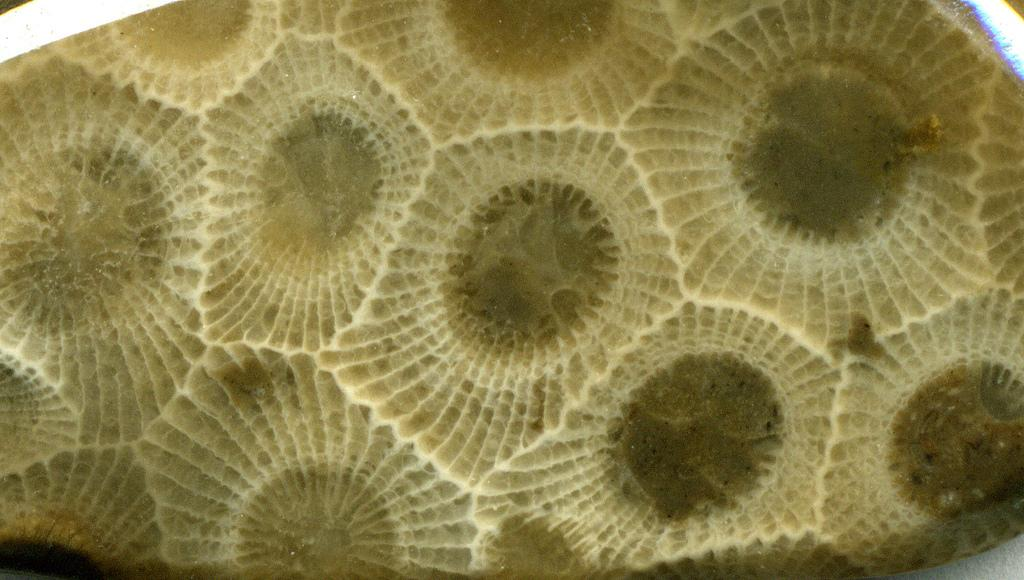What type of object is the main subject of the image? There is a Petoskey stone in the image. How many holes can be seen in the Petoskey stone in the image? There is no mention of holes in the provided fact, and therefore it cannot be determined from the image. 